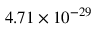Convert formula to latex. <formula><loc_0><loc_0><loc_500><loc_500>4 . 7 1 \times 1 0 ^ { - 2 9 }</formula> 